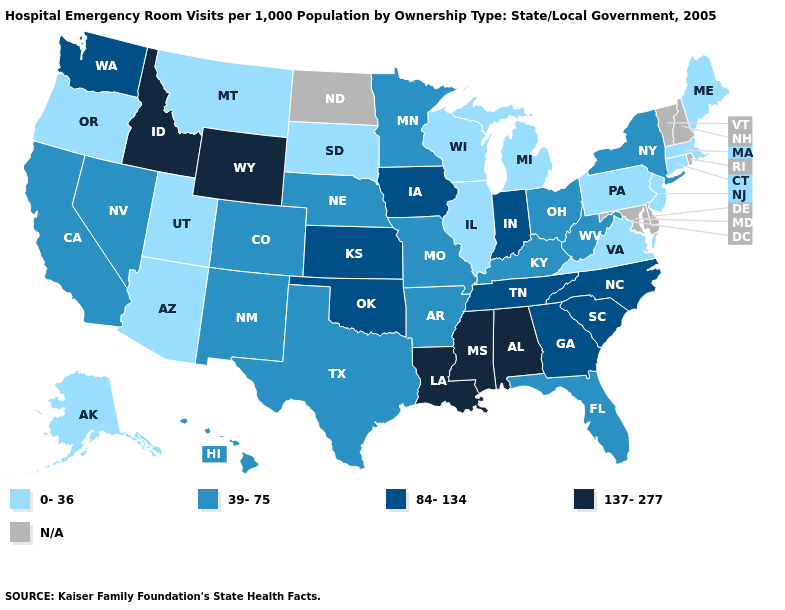What is the value of Nebraska?
Give a very brief answer. 39-75. Name the states that have a value in the range 84-134?
Be succinct. Georgia, Indiana, Iowa, Kansas, North Carolina, Oklahoma, South Carolina, Tennessee, Washington. Among the states that border Florida , does Alabama have the highest value?
Concise answer only. Yes. Does the first symbol in the legend represent the smallest category?
Write a very short answer. Yes. What is the value of Wisconsin?
Be succinct. 0-36. Among the states that border North Carolina , does South Carolina have the highest value?
Give a very brief answer. Yes. What is the highest value in the USA?
Keep it brief. 137-277. What is the highest value in the USA?
Quick response, please. 137-277. Which states have the lowest value in the MidWest?
Short answer required. Illinois, Michigan, South Dakota, Wisconsin. What is the value of California?
Keep it brief. 39-75. Does the first symbol in the legend represent the smallest category?
Be succinct. Yes. Name the states that have a value in the range 0-36?
Quick response, please. Alaska, Arizona, Connecticut, Illinois, Maine, Massachusetts, Michigan, Montana, New Jersey, Oregon, Pennsylvania, South Dakota, Utah, Virginia, Wisconsin. Does Arkansas have the highest value in the South?
Quick response, please. No. 